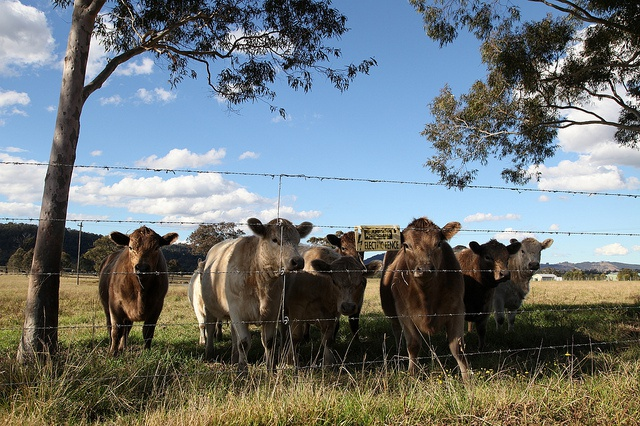Describe the objects in this image and their specific colors. I can see cow in darkgray, black, and gray tones, cow in darkgray, black, maroon, and gray tones, cow in darkgray, black, maroon, and gray tones, cow in darkgray, black, and gray tones, and cow in darkgray, black, maroon, and gray tones in this image. 